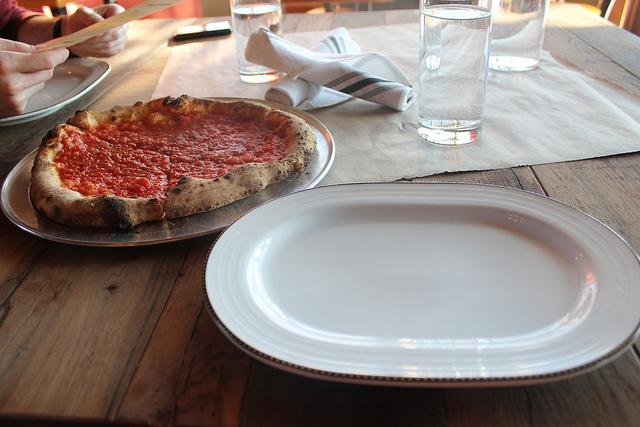Why is the plate empty?

Choices:
A) for customer
B) to throw
C) mistake
D) not hungry for customer 